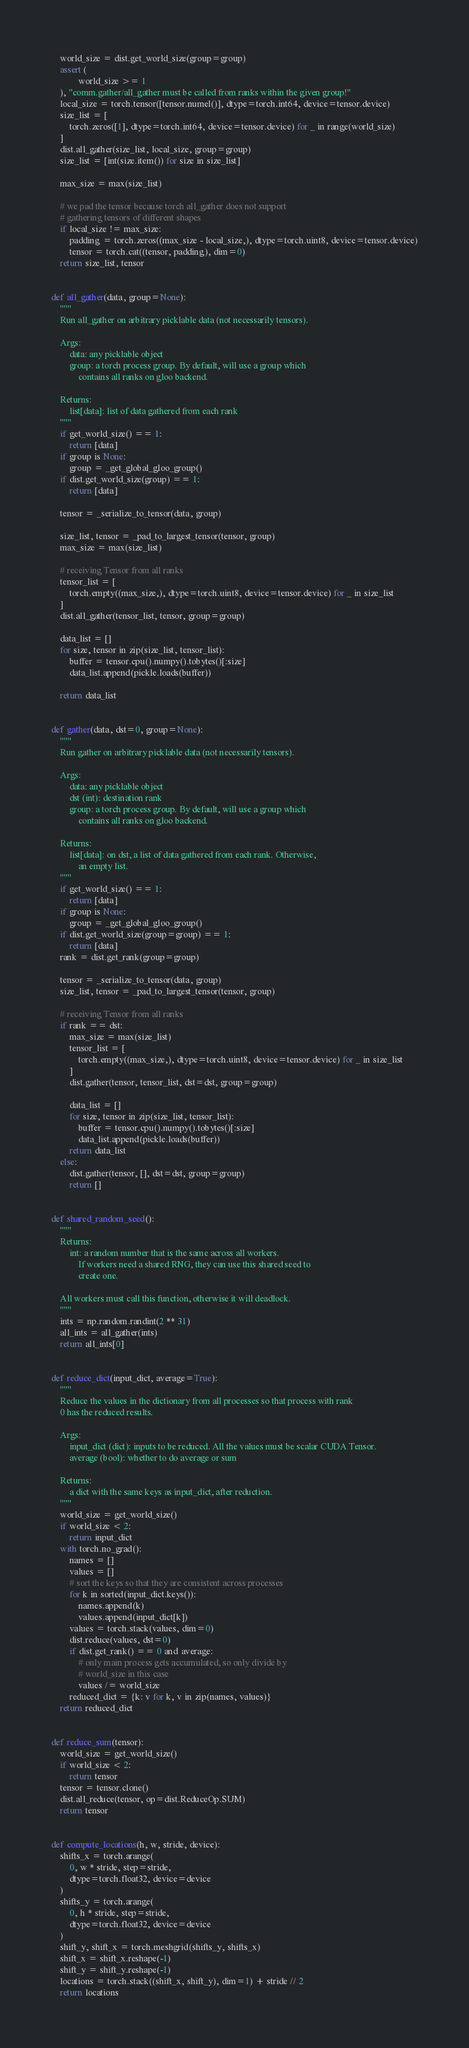<code> <loc_0><loc_0><loc_500><loc_500><_Python_>    world_size = dist.get_world_size(group=group)
    assert (
            world_size >= 1
    ), "comm.gather/all_gather must be called from ranks within the given group!"
    local_size = torch.tensor([tensor.numel()], dtype=torch.int64, device=tensor.device)
    size_list = [
        torch.zeros([1], dtype=torch.int64, device=tensor.device) for _ in range(world_size)
    ]
    dist.all_gather(size_list, local_size, group=group)
    size_list = [int(size.item()) for size in size_list]

    max_size = max(size_list)

    # we pad the tensor because torch all_gather does not support
    # gathering tensors of different shapes
    if local_size != max_size:
        padding = torch.zeros((max_size - local_size,), dtype=torch.uint8, device=tensor.device)
        tensor = torch.cat((tensor, padding), dim=0)
    return size_list, tensor


def all_gather(data, group=None):
    """
    Run all_gather on arbitrary picklable data (not necessarily tensors).

    Args:
        data: any picklable object
        group: a torch process group. By default, will use a group which
            contains all ranks on gloo backend.

    Returns:
        list[data]: list of data gathered from each rank
    """
    if get_world_size() == 1:
        return [data]
    if group is None:
        group = _get_global_gloo_group()
    if dist.get_world_size(group) == 1:
        return [data]

    tensor = _serialize_to_tensor(data, group)

    size_list, tensor = _pad_to_largest_tensor(tensor, group)
    max_size = max(size_list)

    # receiving Tensor from all ranks
    tensor_list = [
        torch.empty((max_size,), dtype=torch.uint8, device=tensor.device) for _ in size_list
    ]
    dist.all_gather(tensor_list, tensor, group=group)

    data_list = []
    for size, tensor in zip(size_list, tensor_list):
        buffer = tensor.cpu().numpy().tobytes()[:size]
        data_list.append(pickle.loads(buffer))

    return data_list


def gather(data, dst=0, group=None):
    """
    Run gather on arbitrary picklable data (not necessarily tensors).

    Args:
        data: any picklable object
        dst (int): destination rank
        group: a torch process group. By default, will use a group which
            contains all ranks on gloo backend.

    Returns:
        list[data]: on dst, a list of data gathered from each rank. Otherwise,
            an empty list.
    """
    if get_world_size() == 1:
        return [data]
    if group is None:
        group = _get_global_gloo_group()
    if dist.get_world_size(group=group) == 1:
        return [data]
    rank = dist.get_rank(group=group)

    tensor = _serialize_to_tensor(data, group)
    size_list, tensor = _pad_to_largest_tensor(tensor, group)

    # receiving Tensor from all ranks
    if rank == dst:
        max_size = max(size_list)
        tensor_list = [
            torch.empty((max_size,), dtype=torch.uint8, device=tensor.device) for _ in size_list
        ]
        dist.gather(tensor, tensor_list, dst=dst, group=group)

        data_list = []
        for size, tensor in zip(size_list, tensor_list):
            buffer = tensor.cpu().numpy().tobytes()[:size]
            data_list.append(pickle.loads(buffer))
        return data_list
    else:
        dist.gather(tensor, [], dst=dst, group=group)
        return []


def shared_random_seed():
    """
    Returns:
        int: a random number that is the same across all workers.
            If workers need a shared RNG, they can use this shared seed to
            create one.

    All workers must call this function, otherwise it will deadlock.
    """
    ints = np.random.randint(2 ** 31)
    all_ints = all_gather(ints)
    return all_ints[0]


def reduce_dict(input_dict, average=True):
    """
    Reduce the values in the dictionary from all processes so that process with rank
    0 has the reduced results.

    Args:
        input_dict (dict): inputs to be reduced. All the values must be scalar CUDA Tensor.
        average (bool): whether to do average or sum

    Returns:
        a dict with the same keys as input_dict, after reduction.
    """
    world_size = get_world_size()
    if world_size < 2:
        return input_dict
    with torch.no_grad():
        names = []
        values = []
        # sort the keys so that they are consistent across processes
        for k in sorted(input_dict.keys()):
            names.append(k)
            values.append(input_dict[k])
        values = torch.stack(values, dim=0)
        dist.reduce(values, dst=0)
        if dist.get_rank() == 0 and average:
            # only main process gets accumulated, so only divide by
            # world_size in this case
            values /= world_size
        reduced_dict = {k: v for k, v in zip(names, values)}
    return reduced_dict


def reduce_sum(tensor):
    world_size = get_world_size()
    if world_size < 2:
        return tensor
    tensor = tensor.clone()
    dist.all_reduce(tensor, op=dist.ReduceOp.SUM)
    return tensor


def compute_locations(h, w, stride, device):
    shifts_x = torch.arange(
        0, w * stride, step=stride,
        dtype=torch.float32, device=device
    )
    shifts_y = torch.arange(
        0, h * stride, step=stride,
        dtype=torch.float32, device=device
    )
    shift_y, shift_x = torch.meshgrid(shifts_y, shifts_x)
    shift_x = shift_x.reshape(-1)
    shift_y = shift_y.reshape(-1)
    locations = torch.stack((shift_x, shift_y), dim=1) + stride // 2
    return locations
</code> 